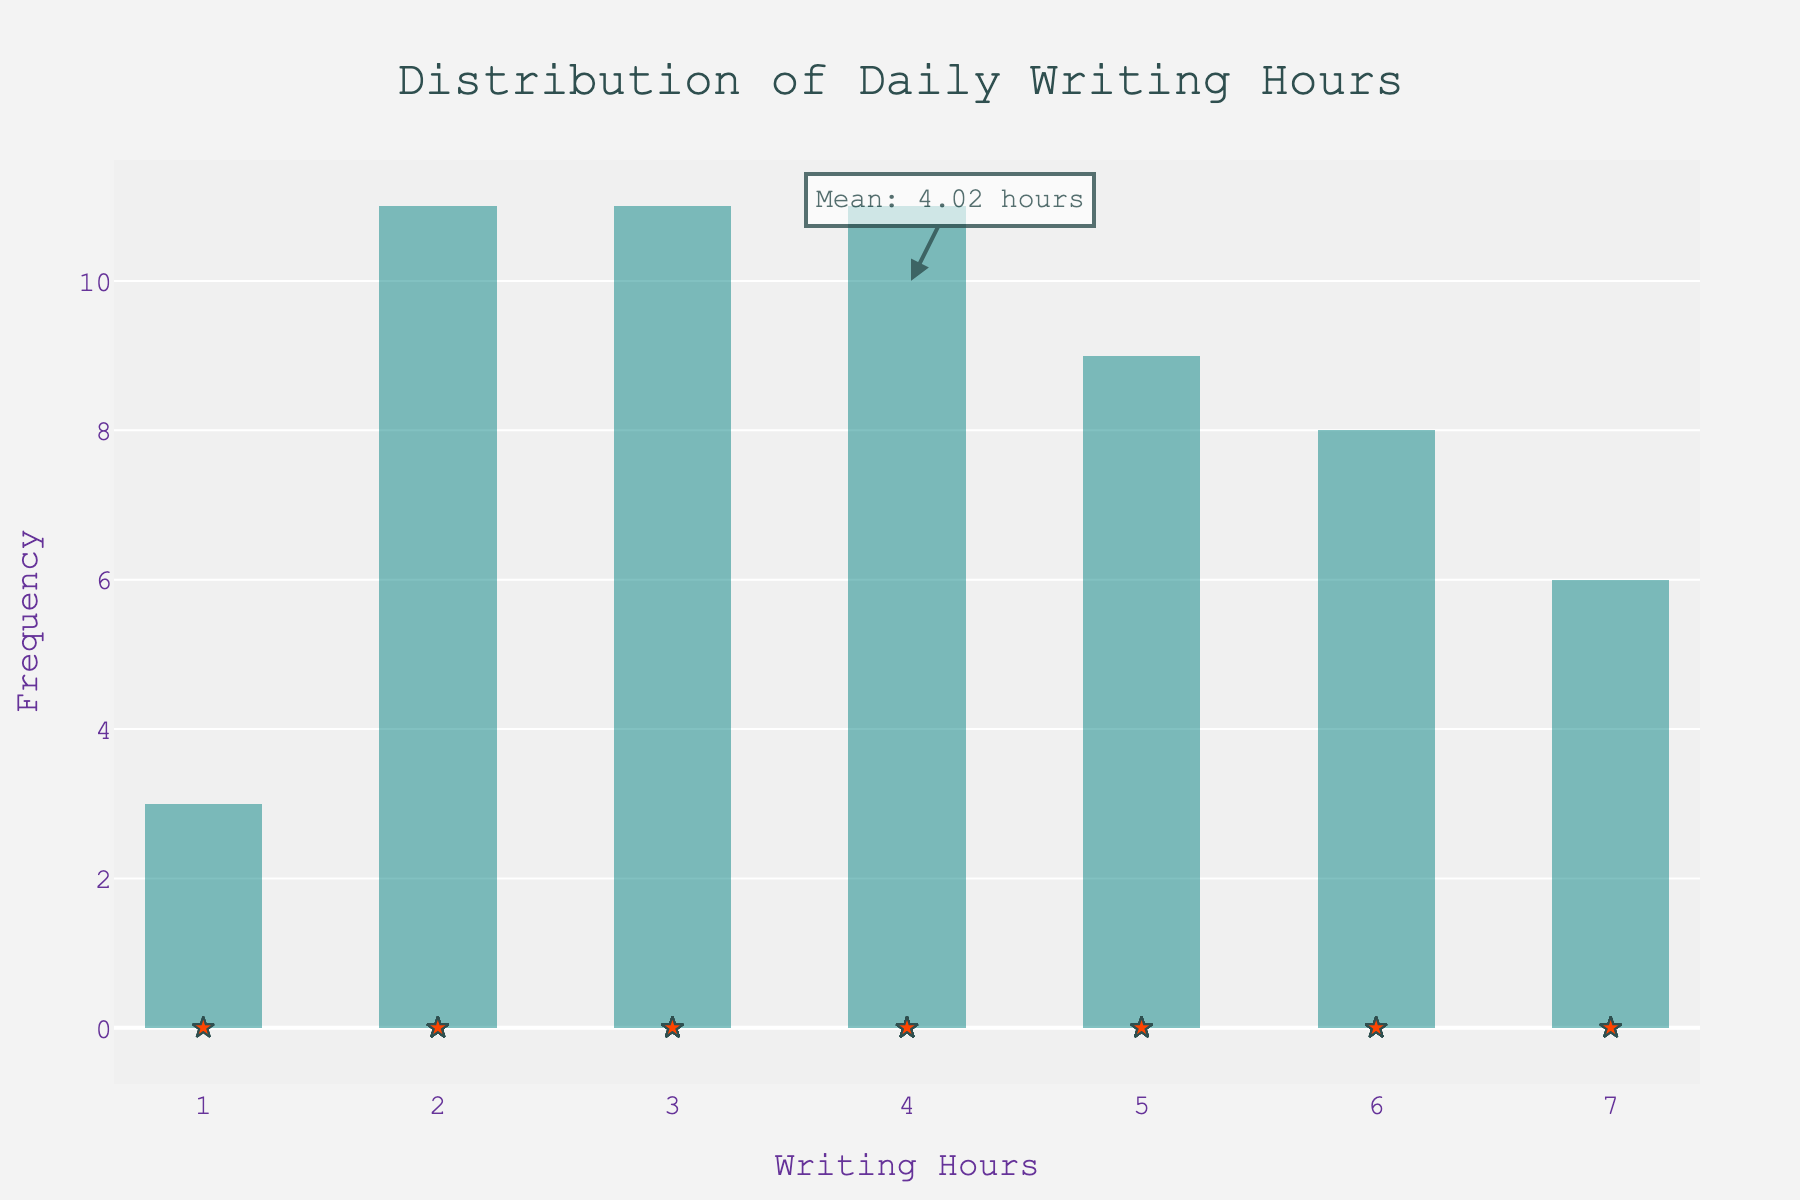What is the title of the plot? The title is located at the top center of the figure, usually in a larger font size. It reads, "Distribution of Daily Writing Hours".
Answer: Distribution of Daily Writing Hours What does the x-axis represent? The x-axis, which runs horizontally along the bottom of the plot, is labeled "Writing Hours". This indicates that the values on this axis represent the number of hours spent writing each day.
Answer: Writing Hours What does the y-axis represent? The y-axis, which runs vertically along the left side of the plot, is labeled "Frequency". This indicates that the values on this axis represent how often each writing hour value occurs.
Answer: Frequency How many bins are there in the histogram? Count the number of vertical bars (bins) in the histogram. In this case, there are 20 bins.
Answer: 20 What is the mean writing hours as indicated on the plot? There's an annotation in the plot with a text box and arrow pointing to the mean value. It states, "Mean: 4.00 hours".
Answer: 4.00 hours What writing hour value occurs most frequently? Observe the height of the bars in the histogram. The tallest bar represents the most frequent writing hours. In this case, the bar corresponding to 4 hours is the tallest.
Answer: 4 hours Is the distribution of daily writing hours skewed? If yes, in which direction? Look at the shape of the histogram. The distribution appears to be fairly symmetric with no long tail on either side, indicating it is not skewed.
Answer: Not skewed What range of writing hours has the least frequency? Identify the bins with the smallest height on the histogram. In this case, writing hours like 1 and 7 have relatively lower frequencies compared to others.
Answer: 1 and 7 hours How do the data points (stars) relate to the histogram bins? Each star represents a specific data point, which is an individual day’s writing hours. They are placed directly below their corresponding bins, indicating the exact value of each data point.
Answer: They represent individual days' writing hours Which value has more data points, 5 hours or 6 hours? Compare the number of stars (data points) located below the bins for 5 hours and 6 hours. The 6 hours bin has more stars (5 data points) compared to the 5 hours bin (4 data points).
Answer: 6 hours 